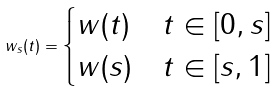<formula> <loc_0><loc_0><loc_500><loc_500>w _ { s } ( t ) = \begin{cases} w ( t ) & t \in [ 0 , s ] \\ w ( s ) & t \in [ s , 1 ] \\ \end{cases}</formula> 